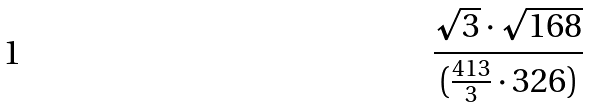Convert formula to latex. <formula><loc_0><loc_0><loc_500><loc_500>\frac { \sqrt { 3 } \cdot \sqrt { 1 6 8 } } { ( \frac { 4 1 3 } { 3 } \cdot 3 2 6 ) }</formula> 